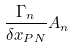Convert formula to latex. <formula><loc_0><loc_0><loc_500><loc_500>\frac { \Gamma _ { n } } { \delta x _ { P N } } A _ { n }</formula> 